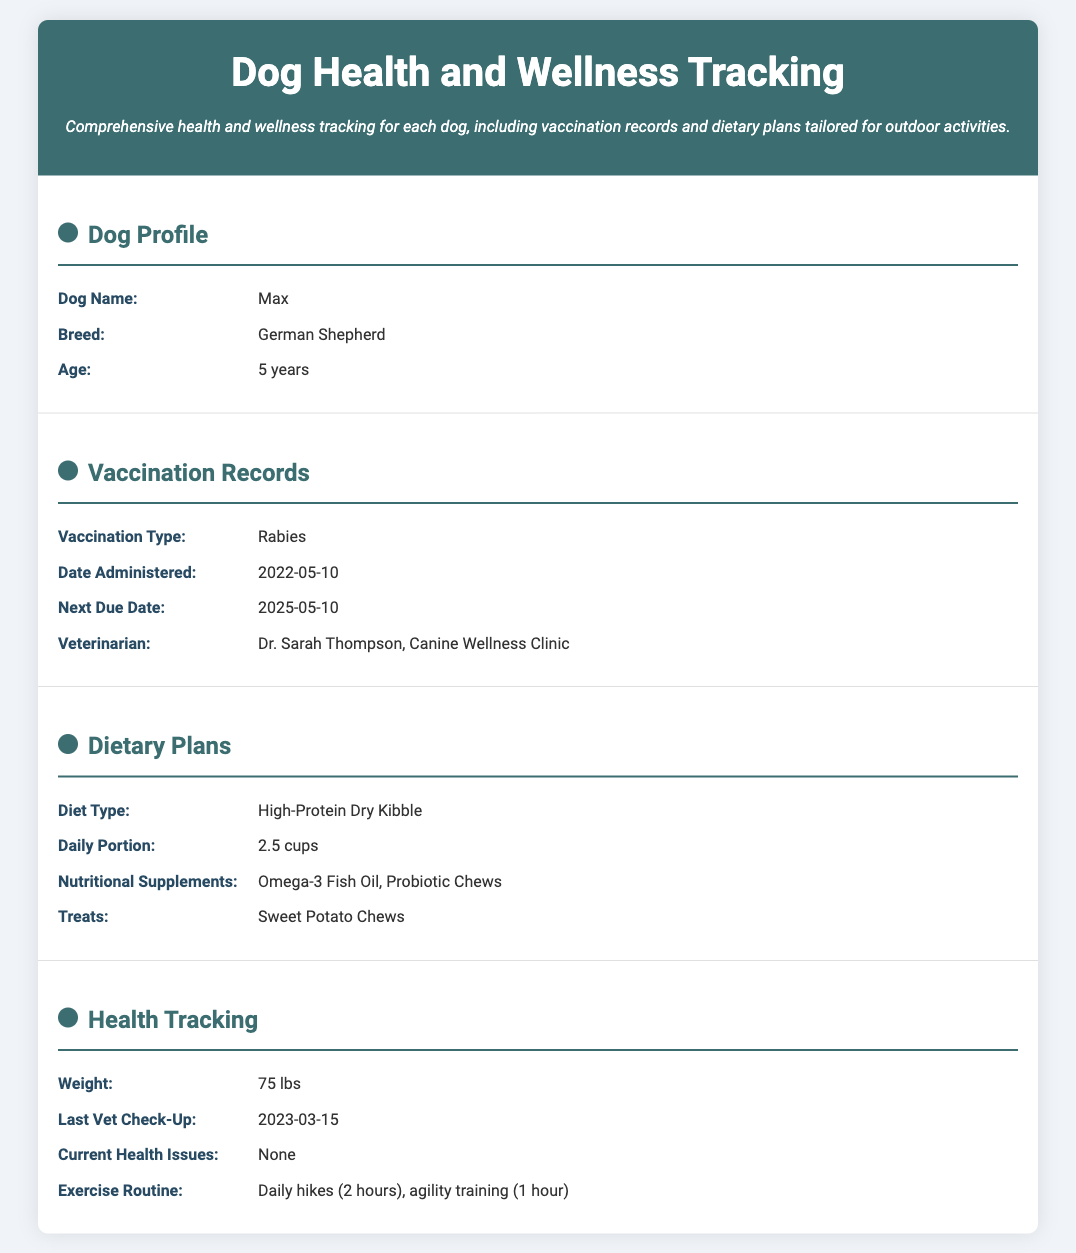What is the dog's name? The dog's name is provided in the Dog Profile section of the document.
Answer: Max What is the dog's breed? The breed of the dog is listed in the Dog Profile section of the document.
Answer: German Shepherd When was the last veterinarian check-up? The date of the last vet check-up can be found in the Health Tracking section of the document.
Answer: 2023-03-15 What is the daily portion of food? The daily portion of food is mentioned in the Dietary Plans section of the document.
Answer: 2.5 cups What nutritional supplements does the dog take? The types of nutritional supplements are specified in the Dietary Plans section.
Answer: Omega-3 Fish Oil, Probiotic Chews What is the next due date for the rabies vaccination? The next due date for the rabies vaccination is provided in the Vaccination Records section.
Answer: 2025-05-10 How much does the dog weigh? The weight of the dog is documented in the Health Tracking section.
Answer: 75 lbs What is the dog's exercise routine? The dog's exercise routine is outlined in the Health Tracking section of the document.
Answer: Daily hikes (2 hours), agility training (1 hour) Which veterinarian administered the last vaccination? The veterinarian who administered the last vaccination can be found in the Vaccination Records section.
Answer: Dr. Sarah Thompson, Canine Wellness Clinic 